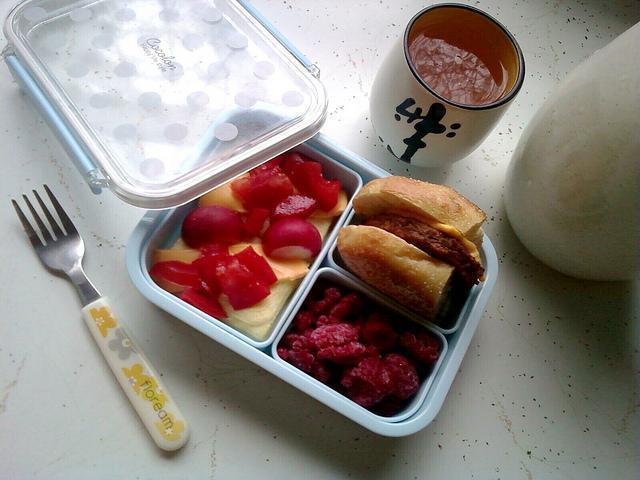What item resembles the item all the way to the left?
Choose the correct response and explain in the format: 'Answer: answer
Rationale: rationale.'
Options: Buzzsaw, pitchfork, chainsaw, gramophone. Answer: pitchfork.
Rationale: The fork has four prongs. 